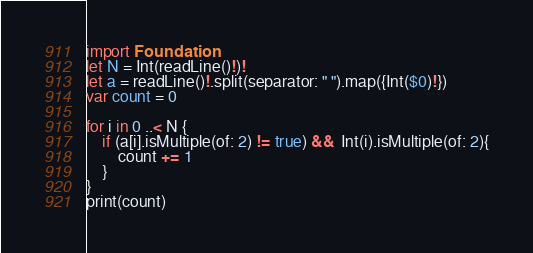Convert code to text. <code><loc_0><loc_0><loc_500><loc_500><_Swift_>import Foundation
let N = Int(readLine()!)!
let a = readLine()!.split(separator: " ").map({Int($0)!})
var count = 0

for i in 0 ..< N {
    if (a[i].isMultiple(of: 2) != true) &&  Int(i).isMultiple(of: 2){
        count += 1
    }
}
print(count)</code> 